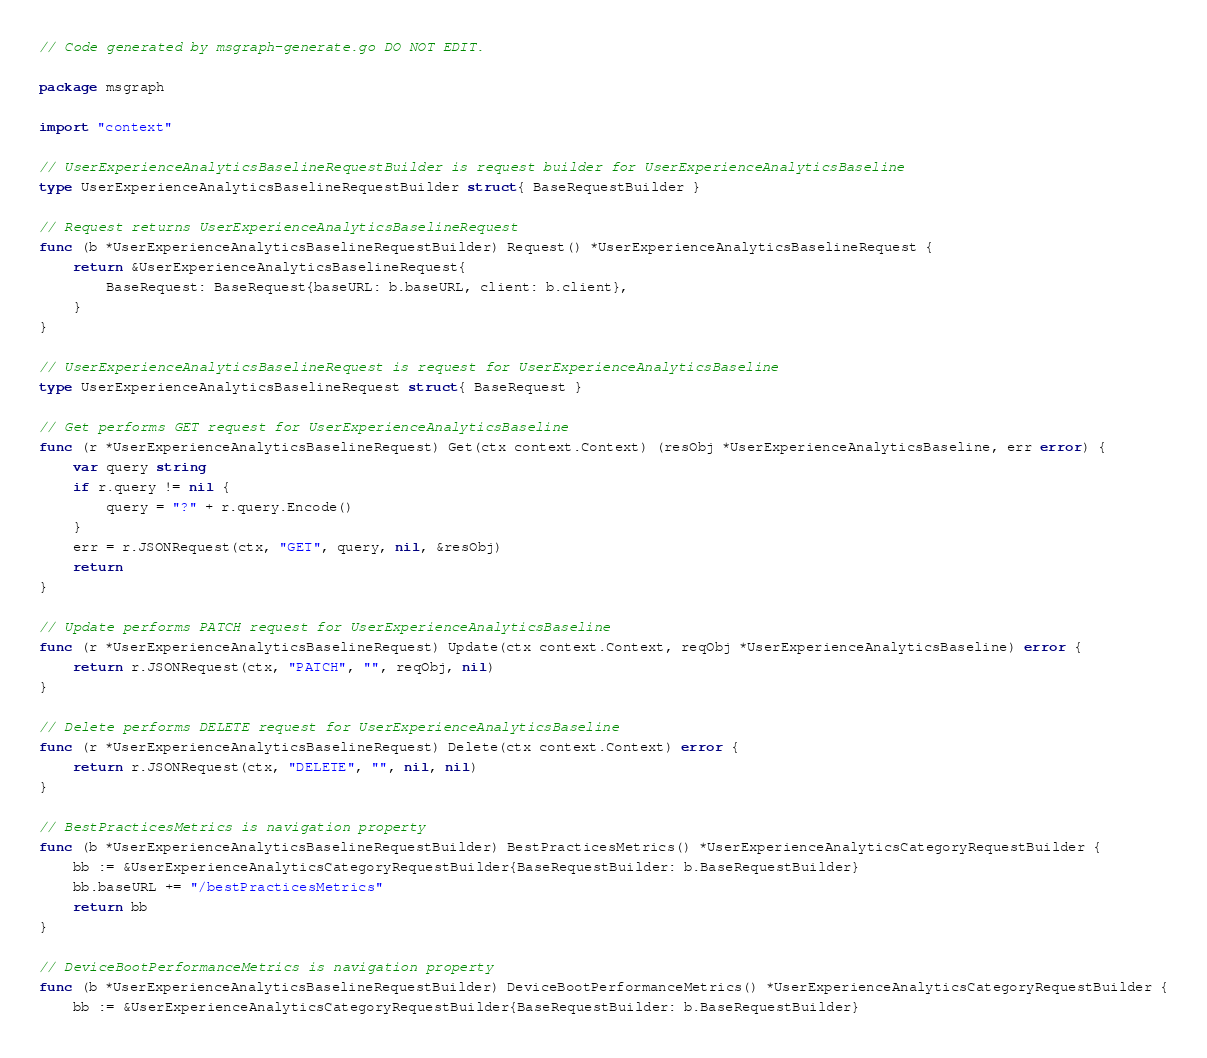Convert code to text. <code><loc_0><loc_0><loc_500><loc_500><_Go_>// Code generated by msgraph-generate.go DO NOT EDIT.

package msgraph

import "context"

// UserExperienceAnalyticsBaselineRequestBuilder is request builder for UserExperienceAnalyticsBaseline
type UserExperienceAnalyticsBaselineRequestBuilder struct{ BaseRequestBuilder }

// Request returns UserExperienceAnalyticsBaselineRequest
func (b *UserExperienceAnalyticsBaselineRequestBuilder) Request() *UserExperienceAnalyticsBaselineRequest {
	return &UserExperienceAnalyticsBaselineRequest{
		BaseRequest: BaseRequest{baseURL: b.baseURL, client: b.client},
	}
}

// UserExperienceAnalyticsBaselineRequest is request for UserExperienceAnalyticsBaseline
type UserExperienceAnalyticsBaselineRequest struct{ BaseRequest }

// Get performs GET request for UserExperienceAnalyticsBaseline
func (r *UserExperienceAnalyticsBaselineRequest) Get(ctx context.Context) (resObj *UserExperienceAnalyticsBaseline, err error) {
	var query string
	if r.query != nil {
		query = "?" + r.query.Encode()
	}
	err = r.JSONRequest(ctx, "GET", query, nil, &resObj)
	return
}

// Update performs PATCH request for UserExperienceAnalyticsBaseline
func (r *UserExperienceAnalyticsBaselineRequest) Update(ctx context.Context, reqObj *UserExperienceAnalyticsBaseline) error {
	return r.JSONRequest(ctx, "PATCH", "", reqObj, nil)
}

// Delete performs DELETE request for UserExperienceAnalyticsBaseline
func (r *UserExperienceAnalyticsBaselineRequest) Delete(ctx context.Context) error {
	return r.JSONRequest(ctx, "DELETE", "", nil, nil)
}

// BestPracticesMetrics is navigation property
func (b *UserExperienceAnalyticsBaselineRequestBuilder) BestPracticesMetrics() *UserExperienceAnalyticsCategoryRequestBuilder {
	bb := &UserExperienceAnalyticsCategoryRequestBuilder{BaseRequestBuilder: b.BaseRequestBuilder}
	bb.baseURL += "/bestPracticesMetrics"
	return bb
}

// DeviceBootPerformanceMetrics is navigation property
func (b *UserExperienceAnalyticsBaselineRequestBuilder) DeviceBootPerformanceMetrics() *UserExperienceAnalyticsCategoryRequestBuilder {
	bb := &UserExperienceAnalyticsCategoryRequestBuilder{BaseRequestBuilder: b.BaseRequestBuilder}</code> 